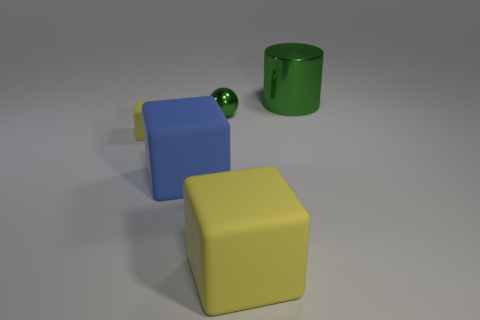There is a small object that is in front of the metallic object that is left of the large object behind the blue rubber object; what is its material?
Make the answer very short. Rubber. How many other things are there of the same size as the blue matte block?
Offer a terse response. 2. There is a blue thing that is the same shape as the small yellow object; what material is it?
Make the answer very short. Rubber. What is the color of the metallic sphere?
Make the answer very short. Green. There is a thing that is to the right of the thing in front of the large blue cube; what color is it?
Provide a succinct answer. Green. Does the tiny rubber block have the same color as the thing that is behind the small green metallic object?
Your answer should be very brief. No. There is a yellow cube behind the large rubber block right of the blue object; how many small yellow cubes are left of it?
Keep it short and to the point. 0. Are there any small matte things in front of the large yellow rubber cube?
Your response must be concise. No. Are there any other things that are the same color as the small ball?
Give a very brief answer. Yes. What number of cylinders are either tiny cyan objects or small yellow things?
Your answer should be compact. 0. 